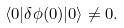<formula> <loc_0><loc_0><loc_500><loc_500>\langle 0 | \delta \phi ( 0 ) | 0 \rangle \neq 0 .</formula> 